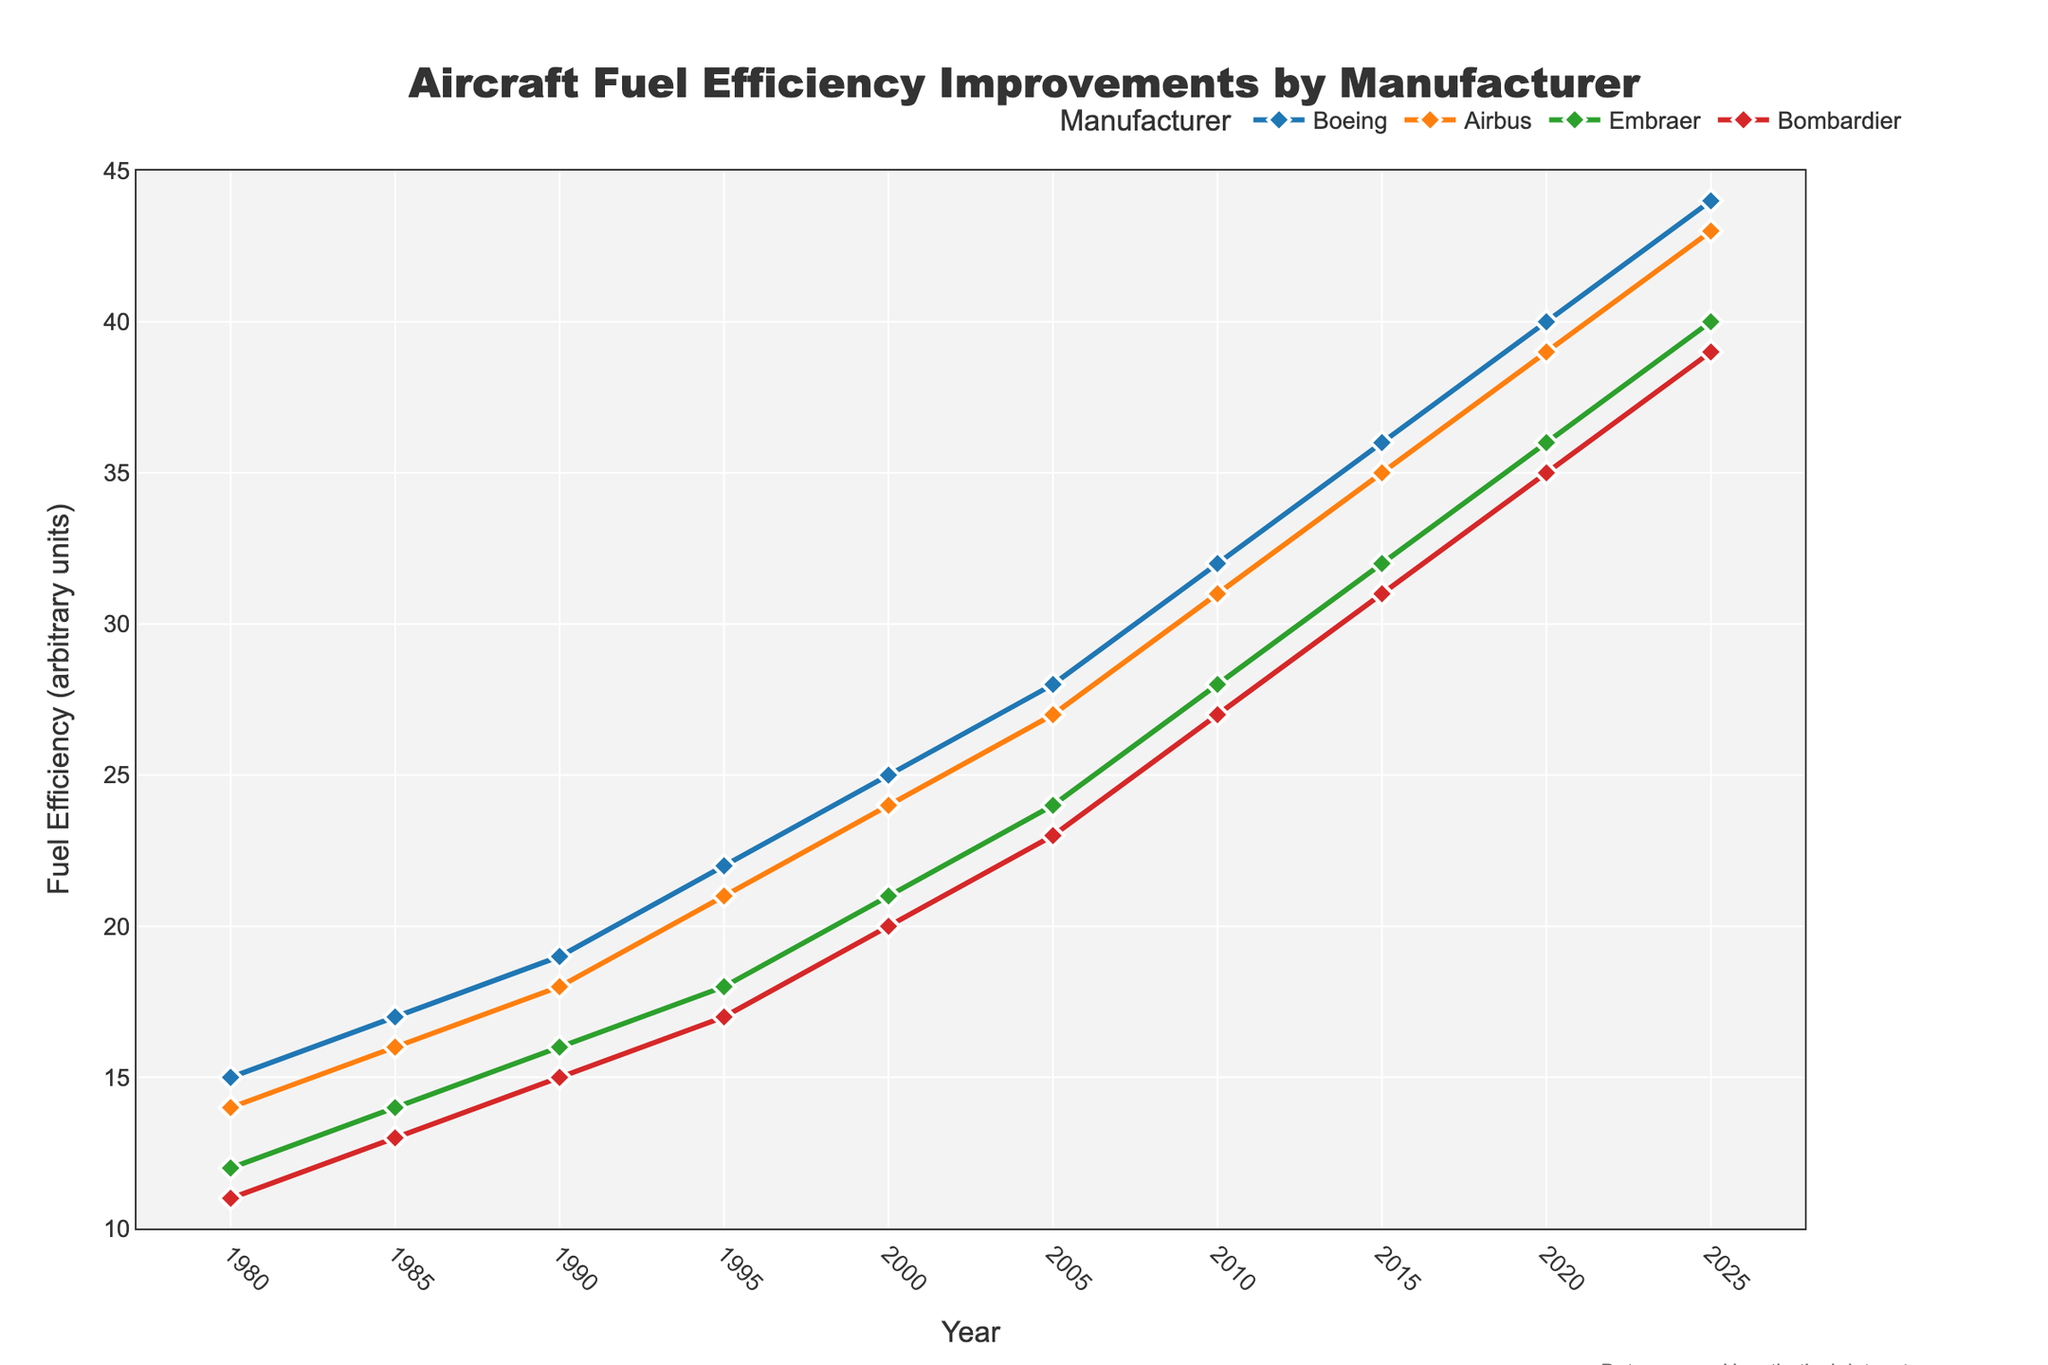What's the fuel efficiency trend for Boeing airliners from 1980 to 2025? To determine the trend, observe the line representing Boeing over the years. From 1980 (15 units) to 2025 (44 units), the fuel efficiency consistently increases with each 5-year interval showing improvement.
Answer: Increasing Which manufacturer had the lowest fuel efficiency in 1985? To find the lowest fuel efficiency in 1985, compare the values for each manufacturer. Boeing had 17, Airbus 16, Embraer 14, and Bombardier 13. Therefore, Bombardier had the lowest fuel efficiency in 1985.
Answer: Bombardier How much did the fuel efficiency for Airbus increase from 2000 to 2015? Compute the difference in fuel efficiency for Airbus between 2015 (35 units) and 2000 (24 units). The increase is 35 - 24 = 11 units.
Answer: 11 units Which two manufacturers had the closest fuel efficiency values in 2010? Compare the 2010 fuel efficiency values: Boeing (32 units), Airbus (31 units), Embraer (28 units), Bombardier (27 units). The smallest difference is between Airbus and Boeing (32 - 31 = 1).
Answer: Boeing and Airbus What is the average fuel efficiency of Bombardier from 1980 to 2025? Compute the average by summing Bombardier's efficiency values (11 + 13 + 15 + 17 + 20 + 23 + 27 + 31 + 35 + 39) and dividing by the total number of years (10). The sum is 211, and the average is 211 / 10 = 21.1 units.
Answer: 21.1 units Who had the highest fuel efficiency in the year 2000? Look at the values for the year 2000: Boeing (25 units), Airbus (24 units), Embraer (21 units), Bombardier (20 units). Boeing had the highest fuel efficiency.
Answer: Boeing By how much did Embraer's fuel efficiency increase between 1980 and 2020 as a percentage of its 1980 value? First, find the increase by subtracting the 1980 value from the 2020 value (36 - 12 = 24). Then, calculate the percentage increase: (24 / 12) * 100 = 200%.
Answer: 200% Which manufacturer shows the most consistent improvement in fuel efficiency over the years? The most consistent improvement would be marked by steady increases. By observing the lines, Boeing shows a steady and consistent increase from 1980 (15 units) to 2025 (44 units) without fluctuations.
Answer: Boeing How does Airbus' fuel efficiency in 2015 compare to Boeing's fuel efficiency in 2005? Airbus' fuel efficiency in 2015 is 35 units, and Boeing's fuel efficiency in 2005 is 28 units. Comparing these, Airbus's 2015 value is higher by 7 units.
Answer: Higher by 7 units 